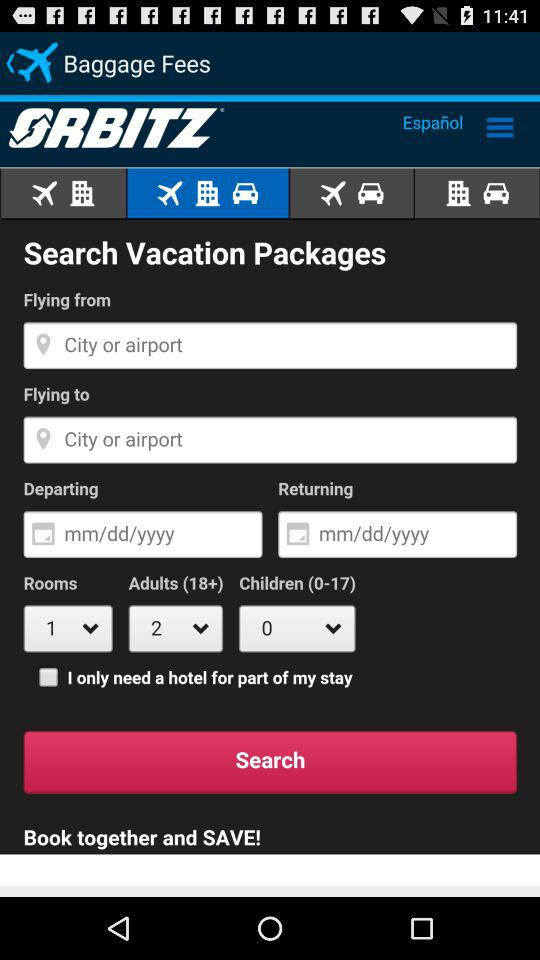How many rooms have been selected? There is 1 room selected. 